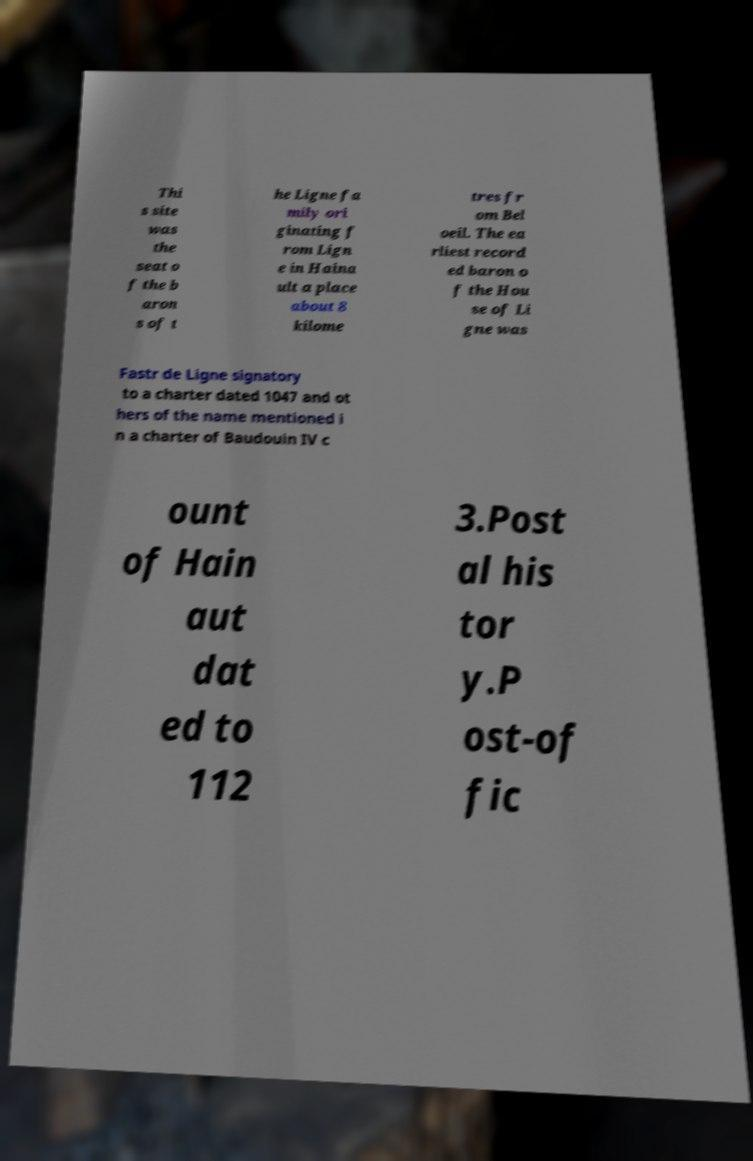Can you accurately transcribe the text from the provided image for me? Thi s site was the seat o f the b aron s of t he Ligne fa mily ori ginating f rom Lign e in Haina ult a place about 8 kilome tres fr om Bel oeil. The ea rliest record ed baron o f the Hou se of Li gne was Fastr de Ligne signatory to a charter dated 1047 and ot hers of the name mentioned i n a charter of Baudouin IV c ount of Hain aut dat ed to 112 3.Post al his tor y.P ost-of fic 